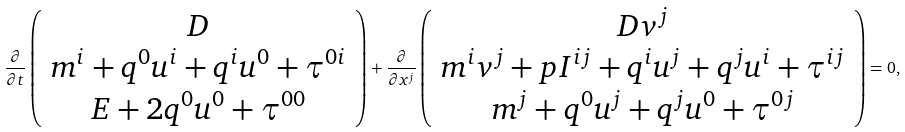<formula> <loc_0><loc_0><loc_500><loc_500>\frac { \partial } { \partial t } \left ( \begin{array} { c } D \\ m ^ { i } + q ^ { 0 } u ^ { i } + q ^ { i } u ^ { 0 } + \tau ^ { 0 i } \\ E + 2 q ^ { 0 } u ^ { 0 } + \tau ^ { 0 0 } \end{array} \right ) + \frac { \partial } { \partial x ^ { j } } \left ( \begin{array} { c } D v ^ { j } \\ m ^ { i } v ^ { j } + p I ^ { i j } + q ^ { i } u ^ { j } + q ^ { j } u ^ { i } + \tau ^ { i j } \\ m ^ { j } + q ^ { 0 } u ^ { j } + q ^ { j } u ^ { 0 } + \tau ^ { 0 j } \\ \end{array} \right ) = 0 ,</formula> 